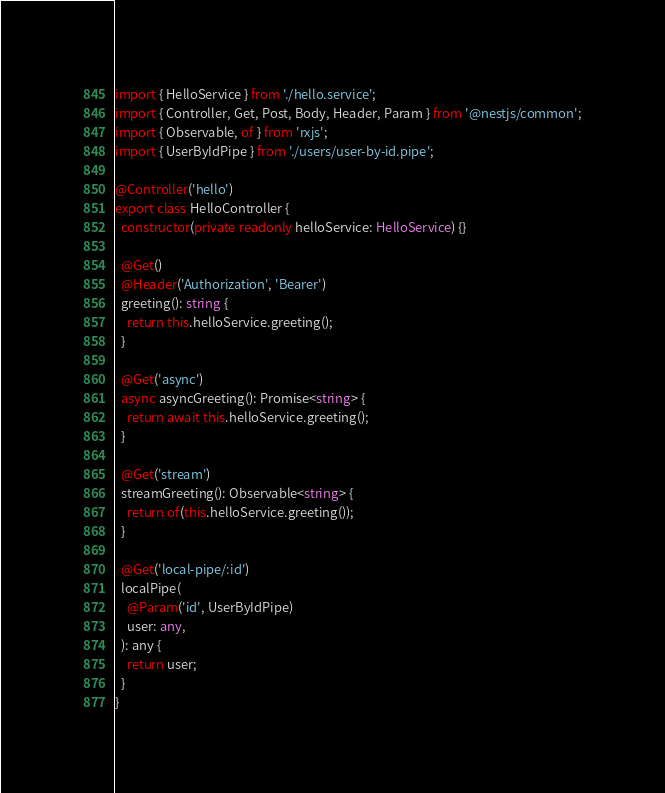<code> <loc_0><loc_0><loc_500><loc_500><_TypeScript_>import { HelloService } from './hello.service';
import { Controller, Get, Post, Body, Header, Param } from '@nestjs/common';
import { Observable, of } from 'rxjs';
import { UserByIdPipe } from './users/user-by-id.pipe';

@Controller('hello')
export class HelloController {
  constructor(private readonly helloService: HelloService) {}

  @Get()
  @Header('Authorization', 'Bearer')
  greeting(): string {
    return this.helloService.greeting();
  }

  @Get('async')
  async asyncGreeting(): Promise<string> {
    return await this.helloService.greeting();
  }

  @Get('stream')
  streamGreeting(): Observable<string> {
    return of(this.helloService.greeting());
  }

  @Get('local-pipe/:id')
  localPipe(
    @Param('id', UserByIdPipe)
    user: any,
  ): any {
    return user;
  }
}
</code> 